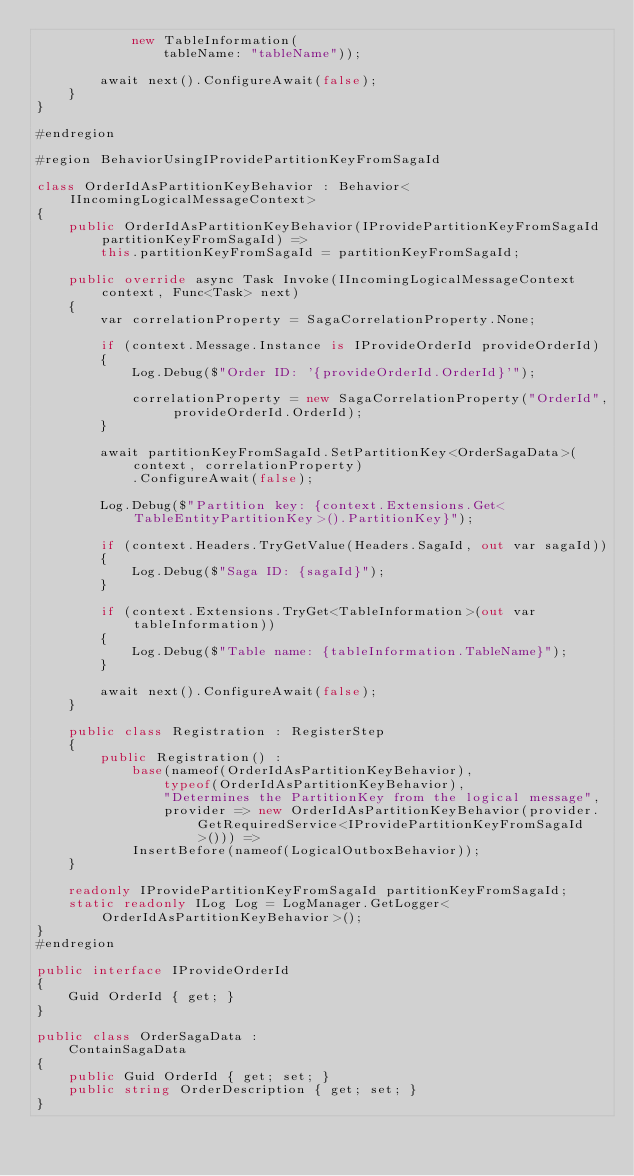<code> <loc_0><loc_0><loc_500><loc_500><_C#_>            new TableInformation(
                tableName: "tableName"));

        await next().ConfigureAwait(false);
    }
}

#endregion

#region BehaviorUsingIProvidePartitionKeyFromSagaId

class OrderIdAsPartitionKeyBehavior : Behavior<IIncomingLogicalMessageContext>
{
    public OrderIdAsPartitionKeyBehavior(IProvidePartitionKeyFromSagaId partitionKeyFromSagaId) =>
        this.partitionKeyFromSagaId = partitionKeyFromSagaId;

    public override async Task Invoke(IIncomingLogicalMessageContext context, Func<Task> next)
    {
        var correlationProperty = SagaCorrelationProperty.None;

        if (context.Message.Instance is IProvideOrderId provideOrderId)
        {
            Log.Debug($"Order ID: '{provideOrderId.OrderId}'");

            correlationProperty = new SagaCorrelationProperty("OrderId", provideOrderId.OrderId);
        }

        await partitionKeyFromSagaId.SetPartitionKey<OrderSagaData>(context, correlationProperty)
            .ConfigureAwait(false);

        Log.Debug($"Partition key: {context.Extensions.Get<TableEntityPartitionKey>().PartitionKey}");

        if (context.Headers.TryGetValue(Headers.SagaId, out var sagaId))
        {
            Log.Debug($"Saga ID: {sagaId}");
        }

        if (context.Extensions.TryGet<TableInformation>(out var tableInformation))
        {
            Log.Debug($"Table name: {tableInformation.TableName}");
        }

        await next().ConfigureAwait(false);
    }

    public class Registration : RegisterStep
    {
        public Registration() :
            base(nameof(OrderIdAsPartitionKeyBehavior),
                typeof(OrderIdAsPartitionKeyBehavior),
                "Determines the PartitionKey from the logical message",
                provider => new OrderIdAsPartitionKeyBehavior(provider.GetRequiredService<IProvidePartitionKeyFromSagaId>())) =>
            InsertBefore(nameof(LogicalOutboxBehavior));
    }

    readonly IProvidePartitionKeyFromSagaId partitionKeyFromSagaId;
    static readonly ILog Log = LogManager.GetLogger<OrderIdAsPartitionKeyBehavior>();
}
#endregion

public interface IProvideOrderId
{
    Guid OrderId { get; }
}

public class OrderSagaData :
    ContainSagaData
{
    public Guid OrderId { get; set; }
    public string OrderDescription { get; set; }
}
</code> 